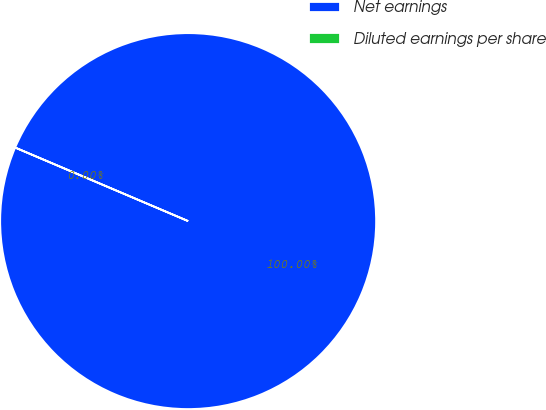<chart> <loc_0><loc_0><loc_500><loc_500><pie_chart><fcel>Net earnings<fcel>Diluted earnings per share<nl><fcel>100.0%<fcel>0.0%<nl></chart> 